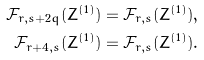<formula> <loc_0><loc_0><loc_500><loc_500>\mathcal { F } _ { r , s + 2 q } ( Z ^ { ( 1 ) } ) & = \mathcal { F } _ { r , s } ( Z ^ { ( 1 ) } ) , \\ \mathcal { F } _ { r + 4 , s } ( Z ^ { ( 1 ) } ) & = \mathcal { F } _ { r , s } ( Z ^ { ( 1 ) } ) .</formula> 